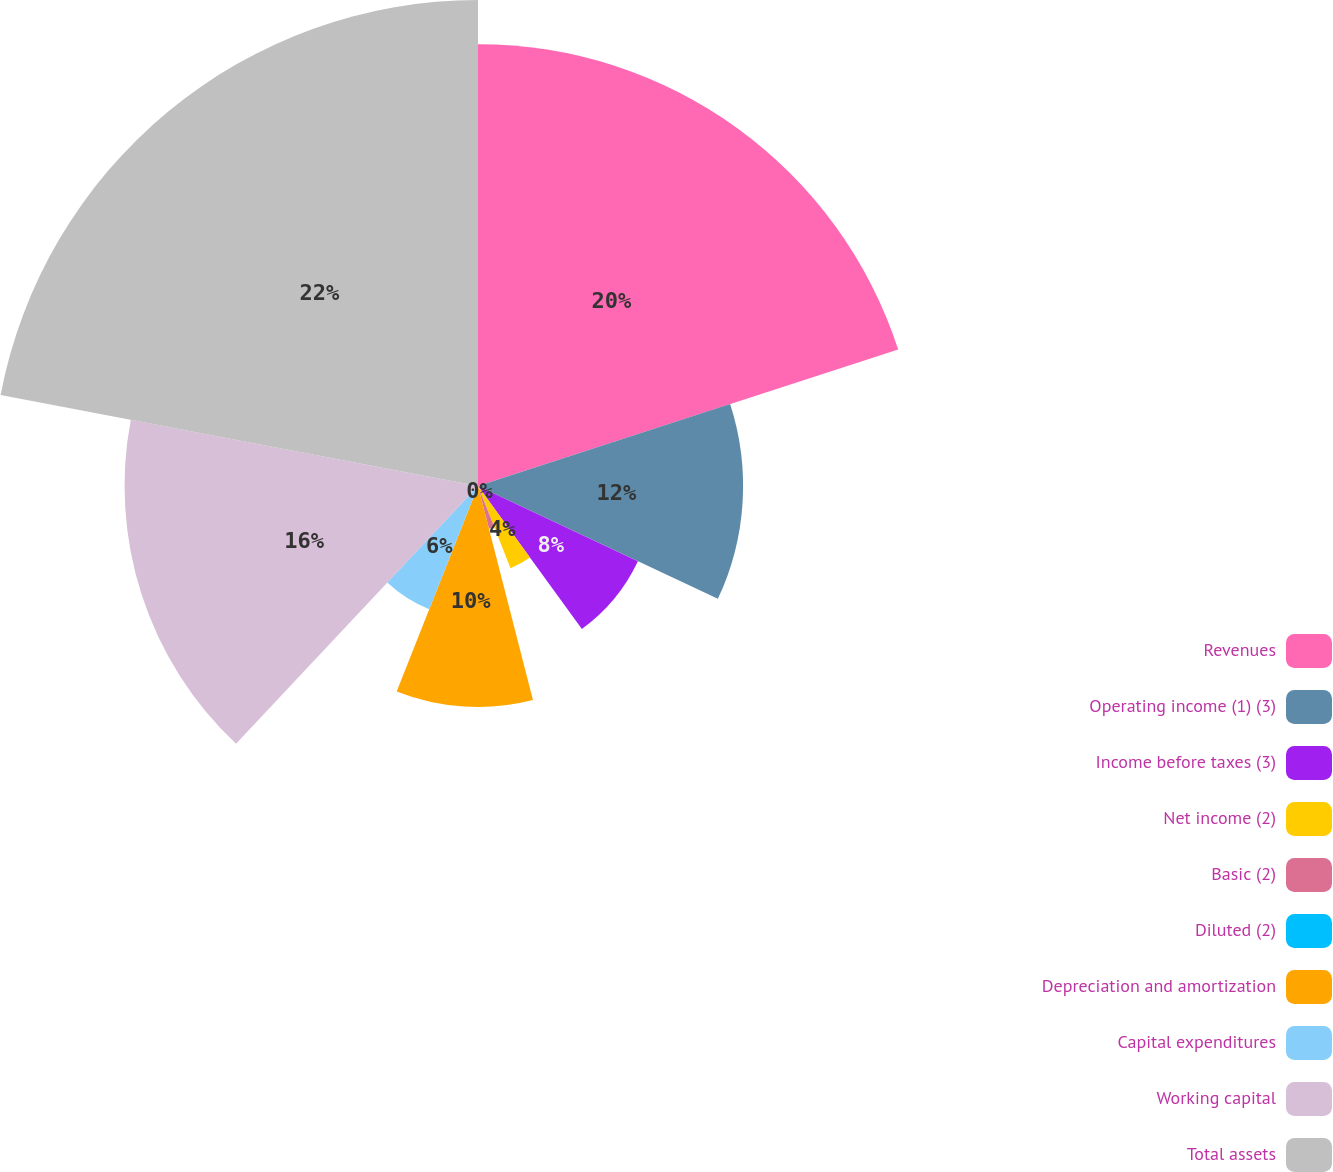<chart> <loc_0><loc_0><loc_500><loc_500><pie_chart><fcel>Revenues<fcel>Operating income (1) (3)<fcel>Income before taxes (3)<fcel>Net income (2)<fcel>Basic (2)<fcel>Diluted (2)<fcel>Depreciation and amortization<fcel>Capital expenditures<fcel>Working capital<fcel>Total assets<nl><fcel>20.0%<fcel>12.0%<fcel>8.0%<fcel>4.0%<fcel>2.0%<fcel>0.0%<fcel>10.0%<fcel>6.0%<fcel>16.0%<fcel>22.0%<nl></chart> 